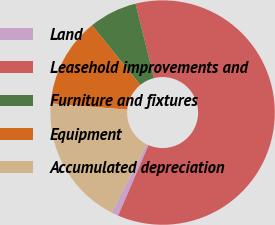Convert chart to OTSL. <chart><loc_0><loc_0><loc_500><loc_500><pie_chart><fcel>Land<fcel>Leasehold improvements and<fcel>Furniture and fixtures<fcel>Equipment<fcel>Accumulated depreciation<nl><fcel>1.01%<fcel>60.35%<fcel>6.95%<fcel>12.88%<fcel>18.81%<nl></chart> 